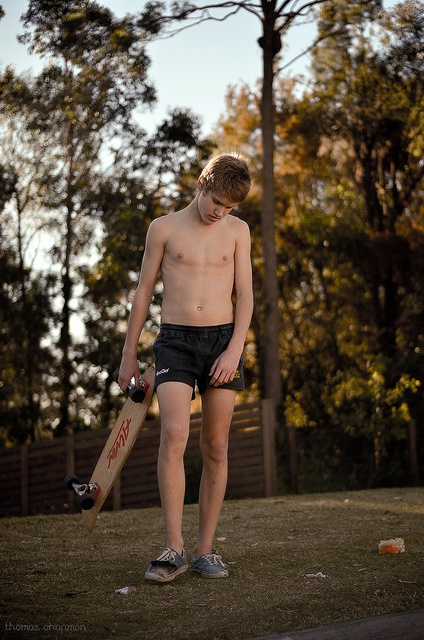Describe the objects in this image and their specific colors. I can see people in lightgray, gray, black, salmon, and brown tones and skateboard in lightgray, gray, black, and maroon tones in this image. 